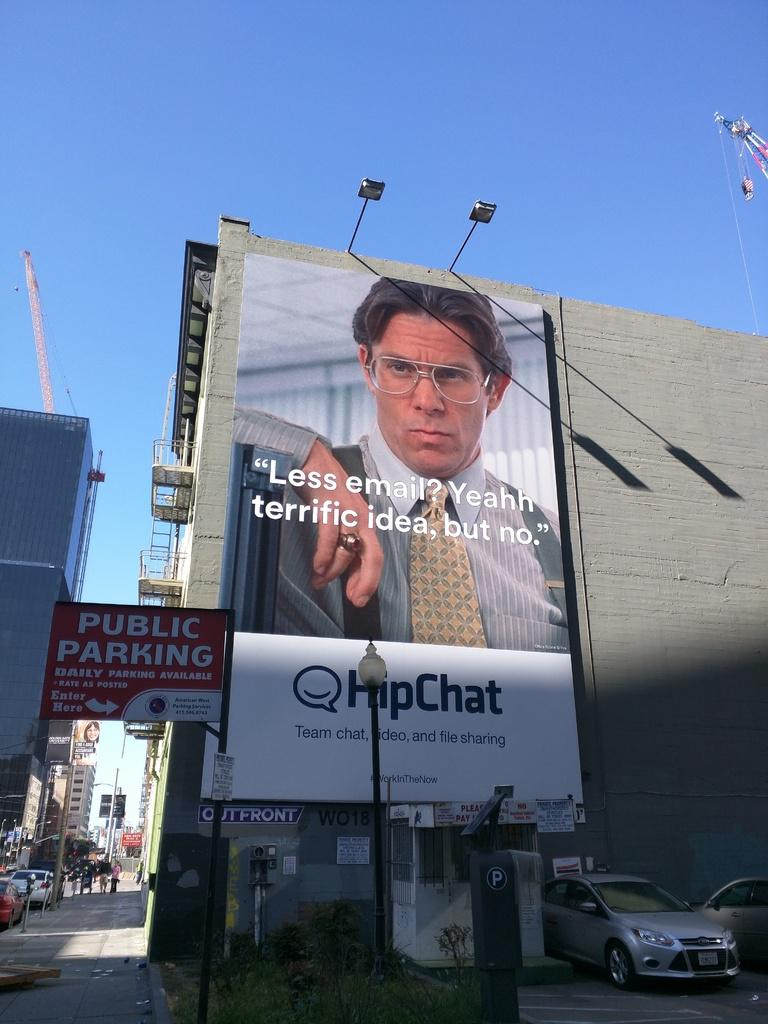Provide a one-sentence caption for the provided image. a large advertisement for hipchat featuring a character from a television show. 